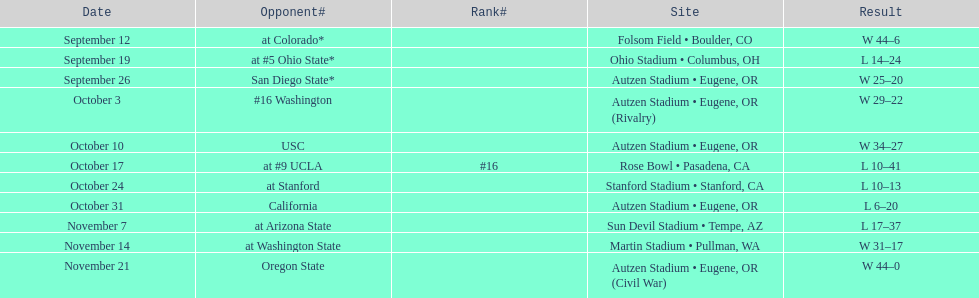Between september 26 and october 24, what was the total number of games held in eugene, or? 3. 